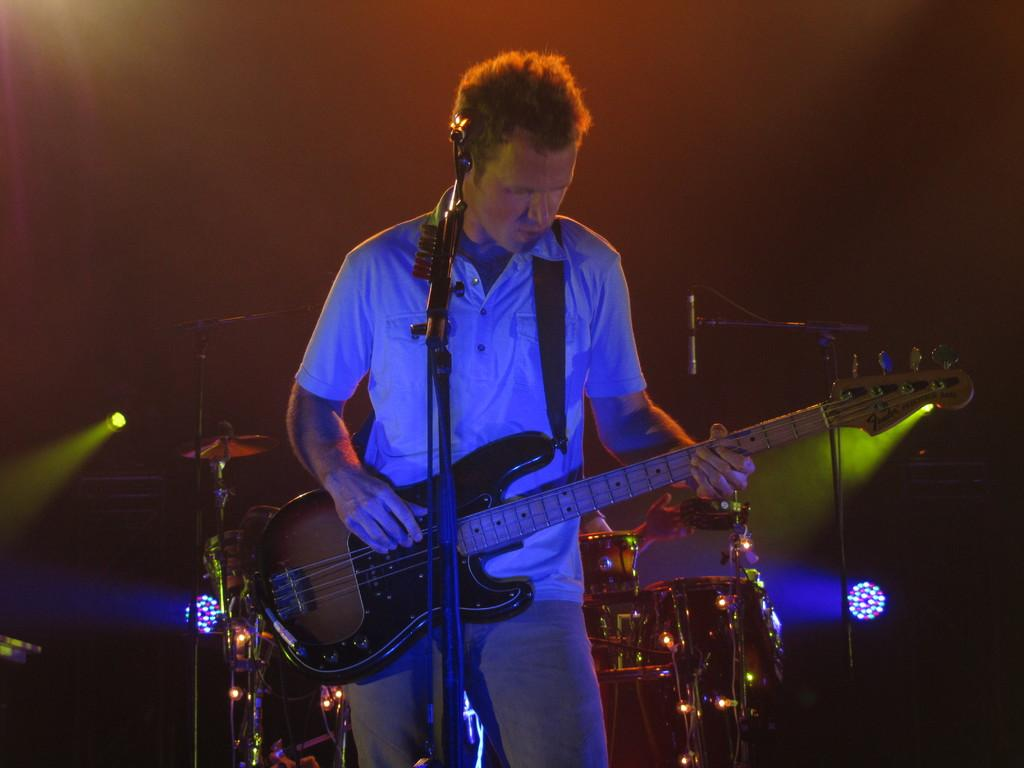What is the man in the image doing? The man is playing a guitar in the image. What object is present in the image that is typically used for amplifying sound? There is a microphone in the image. What type of oven is the man using to cook his meal in the image? There is no oven present in the image; the man is playing a guitar. What decision is the coach making in the image? There is no coach or decision-making process depicted in the image; it features a man playing a guitar and a microphone. 